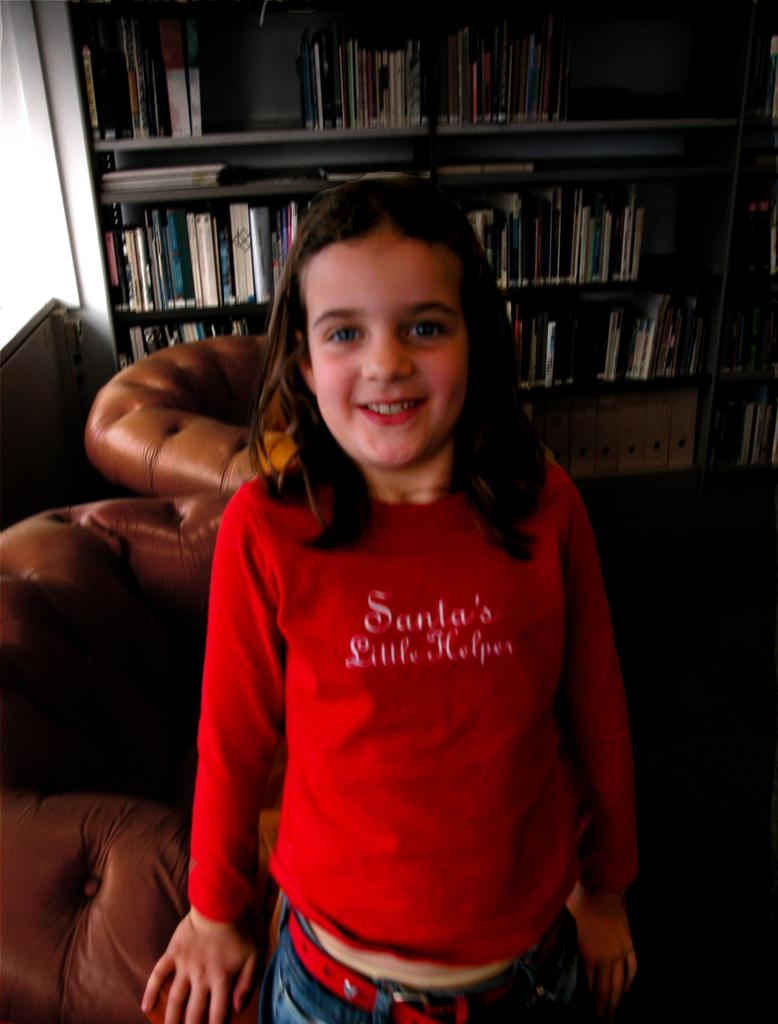<image>
Summarize the visual content of the image. A girl wearing a red Santa's Little Helper shirt standing in front of a bookcase. 